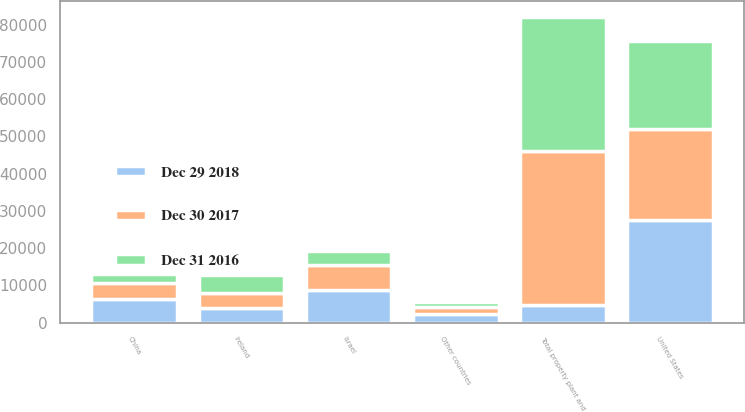Convert chart. <chart><loc_0><loc_0><loc_500><loc_500><stacked_bar_chart><ecel><fcel>United States<fcel>Israel<fcel>China<fcel>Ireland<fcel>Other countries<fcel>Total property plant and<nl><fcel>Dec 29 2018<fcel>27512<fcel>8861<fcel>6417<fcel>3947<fcel>2239<fcel>4865<nl><fcel>Dec 30 2017<fcel>24459<fcel>6501<fcel>4275<fcel>3938<fcel>1936<fcel>41109<nl><fcel>Dec 31 2016<fcel>23598<fcel>3923<fcel>2306<fcel>4865<fcel>1479<fcel>36171<nl></chart> 